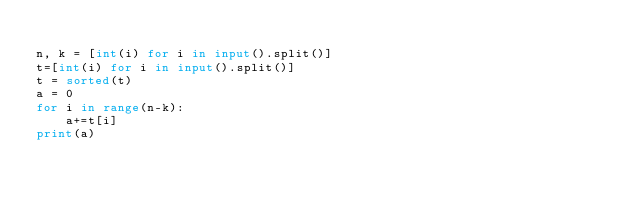<code> <loc_0><loc_0><loc_500><loc_500><_Python_>
n, k = [int(i) for i in input().split()]
t=[int(i) for i in input().split()]
t = sorted(t)
a = 0
for i in range(n-k):
	a+=t[i]
print(a)
</code> 